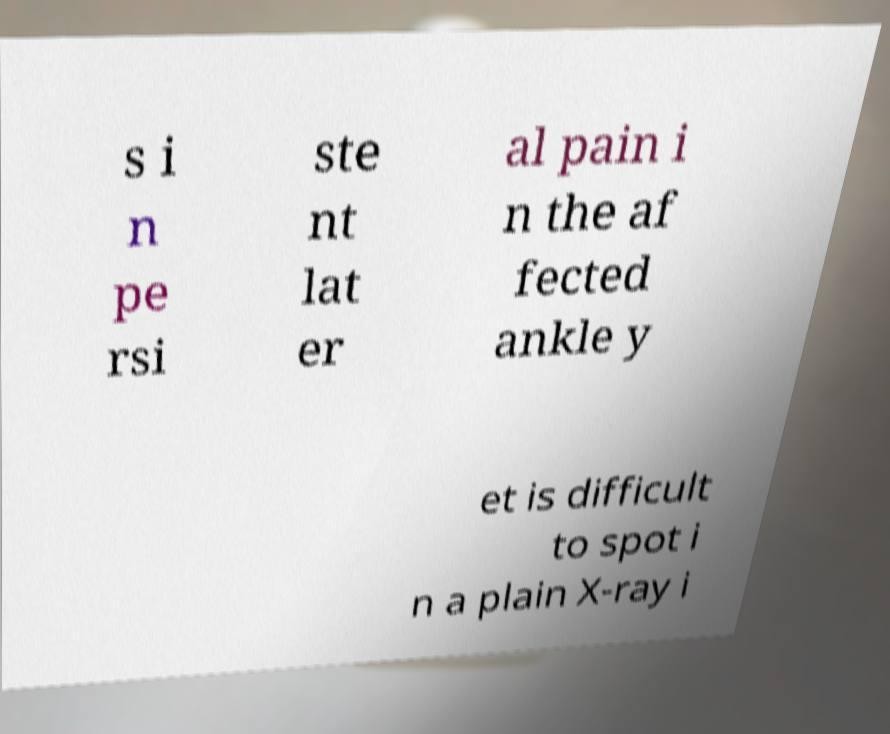Can you accurately transcribe the text from the provided image for me? s i n pe rsi ste nt lat er al pain i n the af fected ankle y et is difficult to spot i n a plain X-ray i 